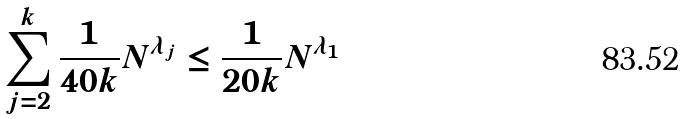Convert formula to latex. <formula><loc_0><loc_0><loc_500><loc_500>\sum _ { j = 2 } ^ { k } \frac { 1 } { 4 0 k } N ^ { \lambda _ { j } } \leq \frac { 1 } { 2 0 k } N ^ { \lambda _ { 1 } }</formula> 